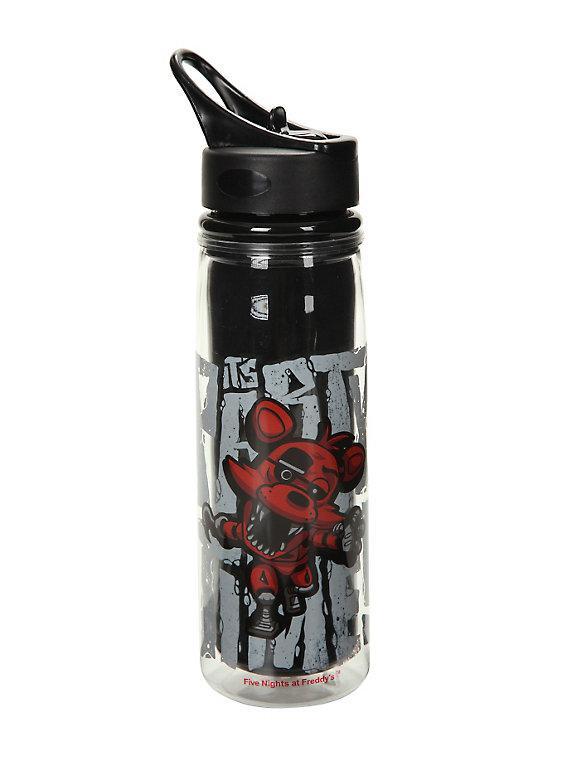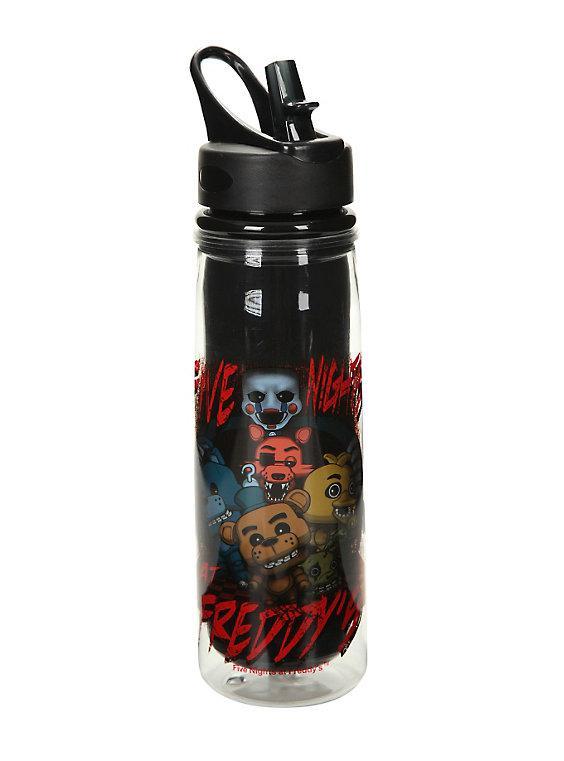The first image is the image on the left, the second image is the image on the right. Considering the images on both sides, is "The left and right image contains a total of two black bottles." valid? Answer yes or no. Yes. The first image is the image on the left, the second image is the image on the right. Analyze the images presented: Is the assertion "Both images contain one mostly black reusable water bottle." valid? Answer yes or no. Yes. 